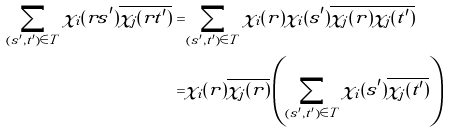<formula> <loc_0><loc_0><loc_500><loc_500>\sum _ { ( s ^ { \prime } , t ^ { \prime } ) \in T } \chi _ { i } ( r s ^ { \prime } ) \overline { \chi _ { j } ( r t ^ { \prime } ) } = & \sum _ { ( s ^ { \prime } , t ^ { \prime } ) \in T } \chi _ { i } ( r ) \chi _ { i } ( s ^ { \prime } ) \overline { \chi _ { j } ( r ) } \overline { \chi _ { j } ( t ^ { \prime } ) } \\ = & \chi _ { i } ( r ) \overline { \chi _ { j } ( r ) } \left ( \sum _ { ( s ^ { \prime } , t ^ { \prime } ) \in T } \chi _ { i } ( s ^ { \prime } ) \overline { \chi _ { j } ( t ^ { \prime } ) } \right )</formula> 